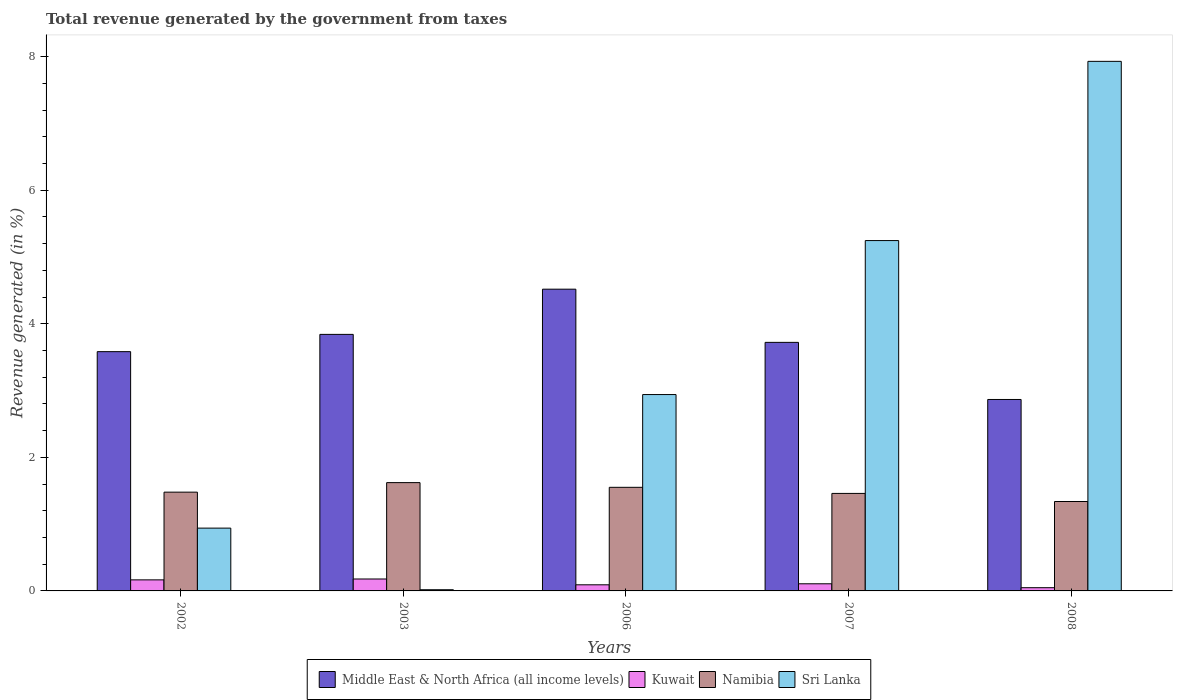How many different coloured bars are there?
Keep it short and to the point. 4. How many groups of bars are there?
Provide a short and direct response. 5. In how many cases, is the number of bars for a given year not equal to the number of legend labels?
Your answer should be compact. 0. What is the total revenue generated in Sri Lanka in 2003?
Provide a succinct answer. 0.02. Across all years, what is the maximum total revenue generated in Kuwait?
Keep it short and to the point. 0.18. Across all years, what is the minimum total revenue generated in Namibia?
Offer a terse response. 1.34. In which year was the total revenue generated in Kuwait maximum?
Make the answer very short. 2003. In which year was the total revenue generated in Kuwait minimum?
Offer a very short reply. 2008. What is the total total revenue generated in Sri Lanka in the graph?
Make the answer very short. 17.08. What is the difference between the total revenue generated in Kuwait in 2003 and that in 2006?
Ensure brevity in your answer.  0.09. What is the difference between the total revenue generated in Kuwait in 2003 and the total revenue generated in Middle East & North Africa (all income levels) in 2006?
Make the answer very short. -4.34. What is the average total revenue generated in Sri Lanka per year?
Your answer should be very brief. 3.42. In the year 2002, what is the difference between the total revenue generated in Sri Lanka and total revenue generated in Namibia?
Your answer should be compact. -0.54. In how many years, is the total revenue generated in Sri Lanka greater than 1.2000000000000002 %?
Keep it short and to the point. 3. What is the ratio of the total revenue generated in Kuwait in 2002 to that in 2006?
Offer a very short reply. 1.81. What is the difference between the highest and the second highest total revenue generated in Sri Lanka?
Keep it short and to the point. 2.68. What is the difference between the highest and the lowest total revenue generated in Sri Lanka?
Ensure brevity in your answer.  7.91. Is the sum of the total revenue generated in Namibia in 2003 and 2007 greater than the maximum total revenue generated in Middle East & North Africa (all income levels) across all years?
Your answer should be compact. No. Is it the case that in every year, the sum of the total revenue generated in Namibia and total revenue generated in Middle East & North Africa (all income levels) is greater than the sum of total revenue generated in Sri Lanka and total revenue generated in Kuwait?
Offer a terse response. Yes. What does the 2nd bar from the left in 2003 represents?
Give a very brief answer. Kuwait. What does the 3rd bar from the right in 2006 represents?
Make the answer very short. Kuwait. Are all the bars in the graph horizontal?
Give a very brief answer. No. What is the difference between two consecutive major ticks on the Y-axis?
Make the answer very short. 2. How many legend labels are there?
Offer a very short reply. 4. What is the title of the graph?
Provide a succinct answer. Total revenue generated by the government from taxes. Does "Australia" appear as one of the legend labels in the graph?
Offer a very short reply. No. What is the label or title of the Y-axis?
Keep it short and to the point. Revenue generated (in %). What is the Revenue generated (in %) of Middle East & North Africa (all income levels) in 2002?
Make the answer very short. 3.58. What is the Revenue generated (in %) in Kuwait in 2002?
Keep it short and to the point. 0.17. What is the Revenue generated (in %) of Namibia in 2002?
Your answer should be very brief. 1.48. What is the Revenue generated (in %) of Sri Lanka in 2002?
Give a very brief answer. 0.94. What is the Revenue generated (in %) of Middle East & North Africa (all income levels) in 2003?
Keep it short and to the point. 3.84. What is the Revenue generated (in %) in Kuwait in 2003?
Keep it short and to the point. 0.18. What is the Revenue generated (in %) of Namibia in 2003?
Your response must be concise. 1.62. What is the Revenue generated (in %) of Sri Lanka in 2003?
Provide a short and direct response. 0.02. What is the Revenue generated (in %) in Middle East & North Africa (all income levels) in 2006?
Your response must be concise. 4.52. What is the Revenue generated (in %) in Kuwait in 2006?
Your answer should be compact. 0.09. What is the Revenue generated (in %) of Namibia in 2006?
Make the answer very short. 1.55. What is the Revenue generated (in %) in Sri Lanka in 2006?
Your answer should be very brief. 2.94. What is the Revenue generated (in %) of Middle East & North Africa (all income levels) in 2007?
Provide a succinct answer. 3.72. What is the Revenue generated (in %) of Kuwait in 2007?
Your response must be concise. 0.11. What is the Revenue generated (in %) of Namibia in 2007?
Provide a succinct answer. 1.46. What is the Revenue generated (in %) of Sri Lanka in 2007?
Keep it short and to the point. 5.25. What is the Revenue generated (in %) in Middle East & North Africa (all income levels) in 2008?
Make the answer very short. 2.87. What is the Revenue generated (in %) of Kuwait in 2008?
Provide a short and direct response. 0.05. What is the Revenue generated (in %) in Namibia in 2008?
Provide a succinct answer. 1.34. What is the Revenue generated (in %) of Sri Lanka in 2008?
Your answer should be very brief. 7.93. Across all years, what is the maximum Revenue generated (in %) of Middle East & North Africa (all income levels)?
Your answer should be compact. 4.52. Across all years, what is the maximum Revenue generated (in %) in Kuwait?
Ensure brevity in your answer.  0.18. Across all years, what is the maximum Revenue generated (in %) in Namibia?
Provide a short and direct response. 1.62. Across all years, what is the maximum Revenue generated (in %) in Sri Lanka?
Your response must be concise. 7.93. Across all years, what is the minimum Revenue generated (in %) in Middle East & North Africa (all income levels)?
Make the answer very short. 2.87. Across all years, what is the minimum Revenue generated (in %) of Kuwait?
Your response must be concise. 0.05. Across all years, what is the minimum Revenue generated (in %) in Namibia?
Offer a very short reply. 1.34. Across all years, what is the minimum Revenue generated (in %) in Sri Lanka?
Make the answer very short. 0.02. What is the total Revenue generated (in %) in Middle East & North Africa (all income levels) in the graph?
Your answer should be compact. 18.53. What is the total Revenue generated (in %) of Kuwait in the graph?
Make the answer very short. 0.59. What is the total Revenue generated (in %) of Namibia in the graph?
Provide a succinct answer. 7.45. What is the total Revenue generated (in %) in Sri Lanka in the graph?
Ensure brevity in your answer.  17.07. What is the difference between the Revenue generated (in %) of Middle East & North Africa (all income levels) in 2002 and that in 2003?
Keep it short and to the point. -0.26. What is the difference between the Revenue generated (in %) in Kuwait in 2002 and that in 2003?
Provide a short and direct response. -0.01. What is the difference between the Revenue generated (in %) of Namibia in 2002 and that in 2003?
Give a very brief answer. -0.14. What is the difference between the Revenue generated (in %) in Sri Lanka in 2002 and that in 2003?
Provide a succinct answer. 0.92. What is the difference between the Revenue generated (in %) of Middle East & North Africa (all income levels) in 2002 and that in 2006?
Keep it short and to the point. -0.94. What is the difference between the Revenue generated (in %) of Kuwait in 2002 and that in 2006?
Provide a short and direct response. 0.07. What is the difference between the Revenue generated (in %) of Namibia in 2002 and that in 2006?
Ensure brevity in your answer.  -0.07. What is the difference between the Revenue generated (in %) of Sri Lanka in 2002 and that in 2006?
Your answer should be compact. -2. What is the difference between the Revenue generated (in %) in Middle East & North Africa (all income levels) in 2002 and that in 2007?
Your response must be concise. -0.14. What is the difference between the Revenue generated (in %) in Kuwait in 2002 and that in 2007?
Provide a short and direct response. 0.06. What is the difference between the Revenue generated (in %) in Namibia in 2002 and that in 2007?
Offer a very short reply. 0.02. What is the difference between the Revenue generated (in %) of Sri Lanka in 2002 and that in 2007?
Your answer should be compact. -4.31. What is the difference between the Revenue generated (in %) of Middle East & North Africa (all income levels) in 2002 and that in 2008?
Offer a very short reply. 0.72. What is the difference between the Revenue generated (in %) in Kuwait in 2002 and that in 2008?
Make the answer very short. 0.12. What is the difference between the Revenue generated (in %) of Namibia in 2002 and that in 2008?
Offer a terse response. 0.14. What is the difference between the Revenue generated (in %) in Sri Lanka in 2002 and that in 2008?
Offer a very short reply. -6.99. What is the difference between the Revenue generated (in %) in Middle East & North Africa (all income levels) in 2003 and that in 2006?
Give a very brief answer. -0.68. What is the difference between the Revenue generated (in %) of Kuwait in 2003 and that in 2006?
Provide a succinct answer. 0.09. What is the difference between the Revenue generated (in %) of Namibia in 2003 and that in 2006?
Provide a short and direct response. 0.07. What is the difference between the Revenue generated (in %) in Sri Lanka in 2003 and that in 2006?
Your answer should be very brief. -2.92. What is the difference between the Revenue generated (in %) of Middle East & North Africa (all income levels) in 2003 and that in 2007?
Offer a very short reply. 0.12. What is the difference between the Revenue generated (in %) in Kuwait in 2003 and that in 2007?
Make the answer very short. 0.07. What is the difference between the Revenue generated (in %) in Namibia in 2003 and that in 2007?
Make the answer very short. 0.16. What is the difference between the Revenue generated (in %) in Sri Lanka in 2003 and that in 2007?
Offer a very short reply. -5.23. What is the difference between the Revenue generated (in %) of Middle East & North Africa (all income levels) in 2003 and that in 2008?
Give a very brief answer. 0.97. What is the difference between the Revenue generated (in %) of Kuwait in 2003 and that in 2008?
Your answer should be compact. 0.13. What is the difference between the Revenue generated (in %) in Namibia in 2003 and that in 2008?
Your response must be concise. 0.28. What is the difference between the Revenue generated (in %) of Sri Lanka in 2003 and that in 2008?
Your answer should be very brief. -7.91. What is the difference between the Revenue generated (in %) of Middle East & North Africa (all income levels) in 2006 and that in 2007?
Keep it short and to the point. 0.8. What is the difference between the Revenue generated (in %) in Kuwait in 2006 and that in 2007?
Make the answer very short. -0.02. What is the difference between the Revenue generated (in %) of Namibia in 2006 and that in 2007?
Provide a short and direct response. 0.09. What is the difference between the Revenue generated (in %) in Sri Lanka in 2006 and that in 2007?
Provide a succinct answer. -2.31. What is the difference between the Revenue generated (in %) of Middle East & North Africa (all income levels) in 2006 and that in 2008?
Provide a succinct answer. 1.65. What is the difference between the Revenue generated (in %) of Kuwait in 2006 and that in 2008?
Your response must be concise. 0.04. What is the difference between the Revenue generated (in %) of Namibia in 2006 and that in 2008?
Ensure brevity in your answer.  0.21. What is the difference between the Revenue generated (in %) of Sri Lanka in 2006 and that in 2008?
Offer a very short reply. -4.99. What is the difference between the Revenue generated (in %) of Middle East & North Africa (all income levels) in 2007 and that in 2008?
Ensure brevity in your answer.  0.86. What is the difference between the Revenue generated (in %) in Kuwait in 2007 and that in 2008?
Provide a short and direct response. 0.06. What is the difference between the Revenue generated (in %) in Namibia in 2007 and that in 2008?
Your answer should be compact. 0.12. What is the difference between the Revenue generated (in %) in Sri Lanka in 2007 and that in 2008?
Your answer should be very brief. -2.68. What is the difference between the Revenue generated (in %) in Middle East & North Africa (all income levels) in 2002 and the Revenue generated (in %) in Kuwait in 2003?
Ensure brevity in your answer.  3.4. What is the difference between the Revenue generated (in %) in Middle East & North Africa (all income levels) in 2002 and the Revenue generated (in %) in Namibia in 2003?
Your answer should be very brief. 1.96. What is the difference between the Revenue generated (in %) in Middle East & North Africa (all income levels) in 2002 and the Revenue generated (in %) in Sri Lanka in 2003?
Your response must be concise. 3.56. What is the difference between the Revenue generated (in %) of Kuwait in 2002 and the Revenue generated (in %) of Namibia in 2003?
Ensure brevity in your answer.  -1.46. What is the difference between the Revenue generated (in %) in Kuwait in 2002 and the Revenue generated (in %) in Sri Lanka in 2003?
Provide a short and direct response. 0.15. What is the difference between the Revenue generated (in %) of Namibia in 2002 and the Revenue generated (in %) of Sri Lanka in 2003?
Your answer should be very brief. 1.46. What is the difference between the Revenue generated (in %) of Middle East & North Africa (all income levels) in 2002 and the Revenue generated (in %) of Kuwait in 2006?
Provide a short and direct response. 3.49. What is the difference between the Revenue generated (in %) of Middle East & North Africa (all income levels) in 2002 and the Revenue generated (in %) of Namibia in 2006?
Provide a short and direct response. 2.03. What is the difference between the Revenue generated (in %) of Middle East & North Africa (all income levels) in 2002 and the Revenue generated (in %) of Sri Lanka in 2006?
Ensure brevity in your answer.  0.64. What is the difference between the Revenue generated (in %) of Kuwait in 2002 and the Revenue generated (in %) of Namibia in 2006?
Your answer should be very brief. -1.39. What is the difference between the Revenue generated (in %) of Kuwait in 2002 and the Revenue generated (in %) of Sri Lanka in 2006?
Your response must be concise. -2.77. What is the difference between the Revenue generated (in %) of Namibia in 2002 and the Revenue generated (in %) of Sri Lanka in 2006?
Give a very brief answer. -1.46. What is the difference between the Revenue generated (in %) of Middle East & North Africa (all income levels) in 2002 and the Revenue generated (in %) of Kuwait in 2007?
Give a very brief answer. 3.48. What is the difference between the Revenue generated (in %) in Middle East & North Africa (all income levels) in 2002 and the Revenue generated (in %) in Namibia in 2007?
Your answer should be very brief. 2.12. What is the difference between the Revenue generated (in %) of Middle East & North Africa (all income levels) in 2002 and the Revenue generated (in %) of Sri Lanka in 2007?
Give a very brief answer. -1.66. What is the difference between the Revenue generated (in %) of Kuwait in 2002 and the Revenue generated (in %) of Namibia in 2007?
Your response must be concise. -1.29. What is the difference between the Revenue generated (in %) of Kuwait in 2002 and the Revenue generated (in %) of Sri Lanka in 2007?
Your answer should be very brief. -5.08. What is the difference between the Revenue generated (in %) of Namibia in 2002 and the Revenue generated (in %) of Sri Lanka in 2007?
Your answer should be compact. -3.77. What is the difference between the Revenue generated (in %) of Middle East & North Africa (all income levels) in 2002 and the Revenue generated (in %) of Kuwait in 2008?
Give a very brief answer. 3.53. What is the difference between the Revenue generated (in %) of Middle East & North Africa (all income levels) in 2002 and the Revenue generated (in %) of Namibia in 2008?
Your answer should be very brief. 2.24. What is the difference between the Revenue generated (in %) in Middle East & North Africa (all income levels) in 2002 and the Revenue generated (in %) in Sri Lanka in 2008?
Offer a terse response. -4.35. What is the difference between the Revenue generated (in %) in Kuwait in 2002 and the Revenue generated (in %) in Namibia in 2008?
Offer a very short reply. -1.17. What is the difference between the Revenue generated (in %) of Kuwait in 2002 and the Revenue generated (in %) of Sri Lanka in 2008?
Provide a short and direct response. -7.76. What is the difference between the Revenue generated (in %) in Namibia in 2002 and the Revenue generated (in %) in Sri Lanka in 2008?
Provide a short and direct response. -6.45. What is the difference between the Revenue generated (in %) of Middle East & North Africa (all income levels) in 2003 and the Revenue generated (in %) of Kuwait in 2006?
Your answer should be compact. 3.75. What is the difference between the Revenue generated (in %) in Middle East & North Africa (all income levels) in 2003 and the Revenue generated (in %) in Namibia in 2006?
Your response must be concise. 2.29. What is the difference between the Revenue generated (in %) of Middle East & North Africa (all income levels) in 2003 and the Revenue generated (in %) of Sri Lanka in 2006?
Your answer should be very brief. 0.9. What is the difference between the Revenue generated (in %) in Kuwait in 2003 and the Revenue generated (in %) in Namibia in 2006?
Keep it short and to the point. -1.37. What is the difference between the Revenue generated (in %) in Kuwait in 2003 and the Revenue generated (in %) in Sri Lanka in 2006?
Provide a short and direct response. -2.76. What is the difference between the Revenue generated (in %) in Namibia in 2003 and the Revenue generated (in %) in Sri Lanka in 2006?
Make the answer very short. -1.32. What is the difference between the Revenue generated (in %) in Middle East & North Africa (all income levels) in 2003 and the Revenue generated (in %) in Kuwait in 2007?
Provide a succinct answer. 3.73. What is the difference between the Revenue generated (in %) in Middle East & North Africa (all income levels) in 2003 and the Revenue generated (in %) in Namibia in 2007?
Provide a succinct answer. 2.38. What is the difference between the Revenue generated (in %) of Middle East & North Africa (all income levels) in 2003 and the Revenue generated (in %) of Sri Lanka in 2007?
Offer a terse response. -1.4. What is the difference between the Revenue generated (in %) of Kuwait in 2003 and the Revenue generated (in %) of Namibia in 2007?
Provide a succinct answer. -1.28. What is the difference between the Revenue generated (in %) in Kuwait in 2003 and the Revenue generated (in %) in Sri Lanka in 2007?
Provide a short and direct response. -5.07. What is the difference between the Revenue generated (in %) in Namibia in 2003 and the Revenue generated (in %) in Sri Lanka in 2007?
Your answer should be very brief. -3.62. What is the difference between the Revenue generated (in %) in Middle East & North Africa (all income levels) in 2003 and the Revenue generated (in %) in Kuwait in 2008?
Keep it short and to the point. 3.79. What is the difference between the Revenue generated (in %) of Middle East & North Africa (all income levels) in 2003 and the Revenue generated (in %) of Namibia in 2008?
Give a very brief answer. 2.5. What is the difference between the Revenue generated (in %) in Middle East & North Africa (all income levels) in 2003 and the Revenue generated (in %) in Sri Lanka in 2008?
Keep it short and to the point. -4.09. What is the difference between the Revenue generated (in %) of Kuwait in 2003 and the Revenue generated (in %) of Namibia in 2008?
Ensure brevity in your answer.  -1.16. What is the difference between the Revenue generated (in %) of Kuwait in 2003 and the Revenue generated (in %) of Sri Lanka in 2008?
Provide a succinct answer. -7.75. What is the difference between the Revenue generated (in %) of Namibia in 2003 and the Revenue generated (in %) of Sri Lanka in 2008?
Provide a short and direct response. -6.31. What is the difference between the Revenue generated (in %) of Middle East & North Africa (all income levels) in 2006 and the Revenue generated (in %) of Kuwait in 2007?
Provide a short and direct response. 4.41. What is the difference between the Revenue generated (in %) in Middle East & North Africa (all income levels) in 2006 and the Revenue generated (in %) in Namibia in 2007?
Offer a very short reply. 3.06. What is the difference between the Revenue generated (in %) in Middle East & North Africa (all income levels) in 2006 and the Revenue generated (in %) in Sri Lanka in 2007?
Offer a terse response. -0.73. What is the difference between the Revenue generated (in %) in Kuwait in 2006 and the Revenue generated (in %) in Namibia in 2007?
Your answer should be very brief. -1.37. What is the difference between the Revenue generated (in %) of Kuwait in 2006 and the Revenue generated (in %) of Sri Lanka in 2007?
Provide a succinct answer. -5.15. What is the difference between the Revenue generated (in %) in Namibia in 2006 and the Revenue generated (in %) in Sri Lanka in 2007?
Offer a terse response. -3.69. What is the difference between the Revenue generated (in %) in Middle East & North Africa (all income levels) in 2006 and the Revenue generated (in %) in Kuwait in 2008?
Make the answer very short. 4.47. What is the difference between the Revenue generated (in %) of Middle East & North Africa (all income levels) in 2006 and the Revenue generated (in %) of Namibia in 2008?
Ensure brevity in your answer.  3.18. What is the difference between the Revenue generated (in %) in Middle East & North Africa (all income levels) in 2006 and the Revenue generated (in %) in Sri Lanka in 2008?
Provide a short and direct response. -3.41. What is the difference between the Revenue generated (in %) of Kuwait in 2006 and the Revenue generated (in %) of Namibia in 2008?
Give a very brief answer. -1.25. What is the difference between the Revenue generated (in %) of Kuwait in 2006 and the Revenue generated (in %) of Sri Lanka in 2008?
Provide a succinct answer. -7.84. What is the difference between the Revenue generated (in %) of Namibia in 2006 and the Revenue generated (in %) of Sri Lanka in 2008?
Your answer should be very brief. -6.38. What is the difference between the Revenue generated (in %) in Middle East & North Africa (all income levels) in 2007 and the Revenue generated (in %) in Kuwait in 2008?
Ensure brevity in your answer.  3.67. What is the difference between the Revenue generated (in %) in Middle East & North Africa (all income levels) in 2007 and the Revenue generated (in %) in Namibia in 2008?
Make the answer very short. 2.38. What is the difference between the Revenue generated (in %) of Middle East & North Africa (all income levels) in 2007 and the Revenue generated (in %) of Sri Lanka in 2008?
Ensure brevity in your answer.  -4.21. What is the difference between the Revenue generated (in %) of Kuwait in 2007 and the Revenue generated (in %) of Namibia in 2008?
Offer a very short reply. -1.23. What is the difference between the Revenue generated (in %) in Kuwait in 2007 and the Revenue generated (in %) in Sri Lanka in 2008?
Your answer should be compact. -7.82. What is the difference between the Revenue generated (in %) in Namibia in 2007 and the Revenue generated (in %) in Sri Lanka in 2008?
Provide a succinct answer. -6.47. What is the average Revenue generated (in %) in Middle East & North Africa (all income levels) per year?
Ensure brevity in your answer.  3.71. What is the average Revenue generated (in %) in Kuwait per year?
Your answer should be compact. 0.12. What is the average Revenue generated (in %) in Namibia per year?
Your response must be concise. 1.49. What is the average Revenue generated (in %) of Sri Lanka per year?
Keep it short and to the point. 3.42. In the year 2002, what is the difference between the Revenue generated (in %) in Middle East & North Africa (all income levels) and Revenue generated (in %) in Kuwait?
Provide a succinct answer. 3.42. In the year 2002, what is the difference between the Revenue generated (in %) in Middle East & North Africa (all income levels) and Revenue generated (in %) in Namibia?
Give a very brief answer. 2.1. In the year 2002, what is the difference between the Revenue generated (in %) in Middle East & North Africa (all income levels) and Revenue generated (in %) in Sri Lanka?
Keep it short and to the point. 2.64. In the year 2002, what is the difference between the Revenue generated (in %) in Kuwait and Revenue generated (in %) in Namibia?
Give a very brief answer. -1.31. In the year 2002, what is the difference between the Revenue generated (in %) of Kuwait and Revenue generated (in %) of Sri Lanka?
Provide a succinct answer. -0.77. In the year 2002, what is the difference between the Revenue generated (in %) in Namibia and Revenue generated (in %) in Sri Lanka?
Ensure brevity in your answer.  0.54. In the year 2003, what is the difference between the Revenue generated (in %) in Middle East & North Africa (all income levels) and Revenue generated (in %) in Kuwait?
Offer a very short reply. 3.66. In the year 2003, what is the difference between the Revenue generated (in %) in Middle East & North Africa (all income levels) and Revenue generated (in %) in Namibia?
Offer a very short reply. 2.22. In the year 2003, what is the difference between the Revenue generated (in %) in Middle East & North Africa (all income levels) and Revenue generated (in %) in Sri Lanka?
Give a very brief answer. 3.82. In the year 2003, what is the difference between the Revenue generated (in %) of Kuwait and Revenue generated (in %) of Namibia?
Make the answer very short. -1.44. In the year 2003, what is the difference between the Revenue generated (in %) in Kuwait and Revenue generated (in %) in Sri Lanka?
Offer a terse response. 0.16. In the year 2003, what is the difference between the Revenue generated (in %) of Namibia and Revenue generated (in %) of Sri Lanka?
Your response must be concise. 1.6. In the year 2006, what is the difference between the Revenue generated (in %) of Middle East & North Africa (all income levels) and Revenue generated (in %) of Kuwait?
Ensure brevity in your answer.  4.43. In the year 2006, what is the difference between the Revenue generated (in %) of Middle East & North Africa (all income levels) and Revenue generated (in %) of Namibia?
Offer a terse response. 2.97. In the year 2006, what is the difference between the Revenue generated (in %) in Middle East & North Africa (all income levels) and Revenue generated (in %) in Sri Lanka?
Your response must be concise. 1.58. In the year 2006, what is the difference between the Revenue generated (in %) in Kuwait and Revenue generated (in %) in Namibia?
Offer a terse response. -1.46. In the year 2006, what is the difference between the Revenue generated (in %) in Kuwait and Revenue generated (in %) in Sri Lanka?
Provide a short and direct response. -2.85. In the year 2006, what is the difference between the Revenue generated (in %) in Namibia and Revenue generated (in %) in Sri Lanka?
Your answer should be compact. -1.39. In the year 2007, what is the difference between the Revenue generated (in %) of Middle East & North Africa (all income levels) and Revenue generated (in %) of Kuwait?
Provide a succinct answer. 3.62. In the year 2007, what is the difference between the Revenue generated (in %) of Middle East & North Africa (all income levels) and Revenue generated (in %) of Namibia?
Keep it short and to the point. 2.26. In the year 2007, what is the difference between the Revenue generated (in %) in Middle East & North Africa (all income levels) and Revenue generated (in %) in Sri Lanka?
Offer a very short reply. -1.52. In the year 2007, what is the difference between the Revenue generated (in %) in Kuwait and Revenue generated (in %) in Namibia?
Provide a short and direct response. -1.35. In the year 2007, what is the difference between the Revenue generated (in %) in Kuwait and Revenue generated (in %) in Sri Lanka?
Keep it short and to the point. -5.14. In the year 2007, what is the difference between the Revenue generated (in %) of Namibia and Revenue generated (in %) of Sri Lanka?
Give a very brief answer. -3.79. In the year 2008, what is the difference between the Revenue generated (in %) in Middle East & North Africa (all income levels) and Revenue generated (in %) in Kuwait?
Ensure brevity in your answer.  2.82. In the year 2008, what is the difference between the Revenue generated (in %) of Middle East & North Africa (all income levels) and Revenue generated (in %) of Namibia?
Your answer should be very brief. 1.53. In the year 2008, what is the difference between the Revenue generated (in %) in Middle East & North Africa (all income levels) and Revenue generated (in %) in Sri Lanka?
Provide a short and direct response. -5.06. In the year 2008, what is the difference between the Revenue generated (in %) of Kuwait and Revenue generated (in %) of Namibia?
Make the answer very short. -1.29. In the year 2008, what is the difference between the Revenue generated (in %) of Kuwait and Revenue generated (in %) of Sri Lanka?
Ensure brevity in your answer.  -7.88. In the year 2008, what is the difference between the Revenue generated (in %) in Namibia and Revenue generated (in %) in Sri Lanka?
Your answer should be compact. -6.59. What is the ratio of the Revenue generated (in %) of Middle East & North Africa (all income levels) in 2002 to that in 2003?
Ensure brevity in your answer.  0.93. What is the ratio of the Revenue generated (in %) in Kuwait in 2002 to that in 2003?
Provide a succinct answer. 0.93. What is the ratio of the Revenue generated (in %) of Namibia in 2002 to that in 2003?
Keep it short and to the point. 0.91. What is the ratio of the Revenue generated (in %) in Sri Lanka in 2002 to that in 2003?
Offer a terse response. 52.41. What is the ratio of the Revenue generated (in %) in Middle East & North Africa (all income levels) in 2002 to that in 2006?
Keep it short and to the point. 0.79. What is the ratio of the Revenue generated (in %) of Kuwait in 2002 to that in 2006?
Ensure brevity in your answer.  1.81. What is the ratio of the Revenue generated (in %) of Namibia in 2002 to that in 2006?
Keep it short and to the point. 0.95. What is the ratio of the Revenue generated (in %) of Sri Lanka in 2002 to that in 2006?
Provide a short and direct response. 0.32. What is the ratio of the Revenue generated (in %) of Middle East & North Africa (all income levels) in 2002 to that in 2007?
Your response must be concise. 0.96. What is the ratio of the Revenue generated (in %) of Kuwait in 2002 to that in 2007?
Offer a terse response. 1.55. What is the ratio of the Revenue generated (in %) of Sri Lanka in 2002 to that in 2007?
Your response must be concise. 0.18. What is the ratio of the Revenue generated (in %) of Middle East & North Africa (all income levels) in 2002 to that in 2008?
Offer a very short reply. 1.25. What is the ratio of the Revenue generated (in %) of Kuwait in 2002 to that in 2008?
Ensure brevity in your answer.  3.43. What is the ratio of the Revenue generated (in %) in Namibia in 2002 to that in 2008?
Provide a short and direct response. 1.1. What is the ratio of the Revenue generated (in %) of Sri Lanka in 2002 to that in 2008?
Offer a terse response. 0.12. What is the ratio of the Revenue generated (in %) of Middle East & North Africa (all income levels) in 2003 to that in 2006?
Provide a short and direct response. 0.85. What is the ratio of the Revenue generated (in %) in Kuwait in 2003 to that in 2006?
Keep it short and to the point. 1.95. What is the ratio of the Revenue generated (in %) in Namibia in 2003 to that in 2006?
Ensure brevity in your answer.  1.05. What is the ratio of the Revenue generated (in %) of Sri Lanka in 2003 to that in 2006?
Your response must be concise. 0.01. What is the ratio of the Revenue generated (in %) in Middle East & North Africa (all income levels) in 2003 to that in 2007?
Keep it short and to the point. 1.03. What is the ratio of the Revenue generated (in %) in Kuwait in 2003 to that in 2007?
Ensure brevity in your answer.  1.67. What is the ratio of the Revenue generated (in %) of Namibia in 2003 to that in 2007?
Provide a succinct answer. 1.11. What is the ratio of the Revenue generated (in %) of Sri Lanka in 2003 to that in 2007?
Offer a terse response. 0. What is the ratio of the Revenue generated (in %) of Middle East & North Africa (all income levels) in 2003 to that in 2008?
Give a very brief answer. 1.34. What is the ratio of the Revenue generated (in %) in Kuwait in 2003 to that in 2008?
Your response must be concise. 3.7. What is the ratio of the Revenue generated (in %) of Namibia in 2003 to that in 2008?
Make the answer very short. 1.21. What is the ratio of the Revenue generated (in %) of Sri Lanka in 2003 to that in 2008?
Offer a terse response. 0. What is the ratio of the Revenue generated (in %) of Middle East & North Africa (all income levels) in 2006 to that in 2007?
Offer a very short reply. 1.21. What is the ratio of the Revenue generated (in %) of Kuwait in 2006 to that in 2007?
Provide a short and direct response. 0.86. What is the ratio of the Revenue generated (in %) in Namibia in 2006 to that in 2007?
Your answer should be very brief. 1.06. What is the ratio of the Revenue generated (in %) in Sri Lanka in 2006 to that in 2007?
Ensure brevity in your answer.  0.56. What is the ratio of the Revenue generated (in %) of Middle East & North Africa (all income levels) in 2006 to that in 2008?
Your answer should be very brief. 1.58. What is the ratio of the Revenue generated (in %) in Kuwait in 2006 to that in 2008?
Give a very brief answer. 1.9. What is the ratio of the Revenue generated (in %) of Namibia in 2006 to that in 2008?
Give a very brief answer. 1.16. What is the ratio of the Revenue generated (in %) of Sri Lanka in 2006 to that in 2008?
Keep it short and to the point. 0.37. What is the ratio of the Revenue generated (in %) of Middle East & North Africa (all income levels) in 2007 to that in 2008?
Ensure brevity in your answer.  1.3. What is the ratio of the Revenue generated (in %) of Kuwait in 2007 to that in 2008?
Your response must be concise. 2.21. What is the ratio of the Revenue generated (in %) in Namibia in 2007 to that in 2008?
Offer a terse response. 1.09. What is the ratio of the Revenue generated (in %) in Sri Lanka in 2007 to that in 2008?
Ensure brevity in your answer.  0.66. What is the difference between the highest and the second highest Revenue generated (in %) of Middle East & North Africa (all income levels)?
Provide a succinct answer. 0.68. What is the difference between the highest and the second highest Revenue generated (in %) in Kuwait?
Give a very brief answer. 0.01. What is the difference between the highest and the second highest Revenue generated (in %) of Namibia?
Keep it short and to the point. 0.07. What is the difference between the highest and the second highest Revenue generated (in %) of Sri Lanka?
Keep it short and to the point. 2.68. What is the difference between the highest and the lowest Revenue generated (in %) of Middle East & North Africa (all income levels)?
Make the answer very short. 1.65. What is the difference between the highest and the lowest Revenue generated (in %) of Kuwait?
Your answer should be very brief. 0.13. What is the difference between the highest and the lowest Revenue generated (in %) in Namibia?
Ensure brevity in your answer.  0.28. What is the difference between the highest and the lowest Revenue generated (in %) of Sri Lanka?
Your answer should be very brief. 7.91. 